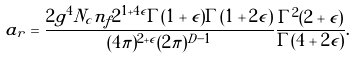Convert formula to latex. <formula><loc_0><loc_0><loc_500><loc_500>a _ { r } = \frac { 2 g ^ { 4 } N _ { c } n _ { f } 2 ^ { 1 + 4 \epsilon } \Gamma ( 1 + \epsilon ) \Gamma ( 1 + 2 \epsilon ) } { ( 4 \pi ) ^ { 2 + \epsilon } ( 2 \pi ) ^ { D - 1 } } \frac { \Gamma ^ { 2 } ( 2 + \epsilon ) } { \Gamma ( 4 + 2 \epsilon ) } .</formula> 